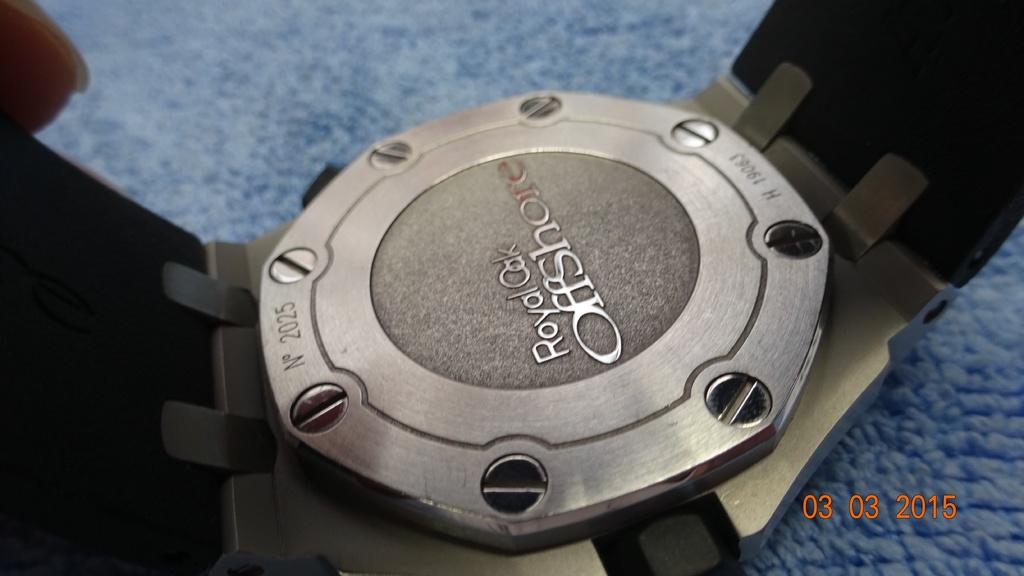What year was this taken?
Your response must be concise. 2015. 